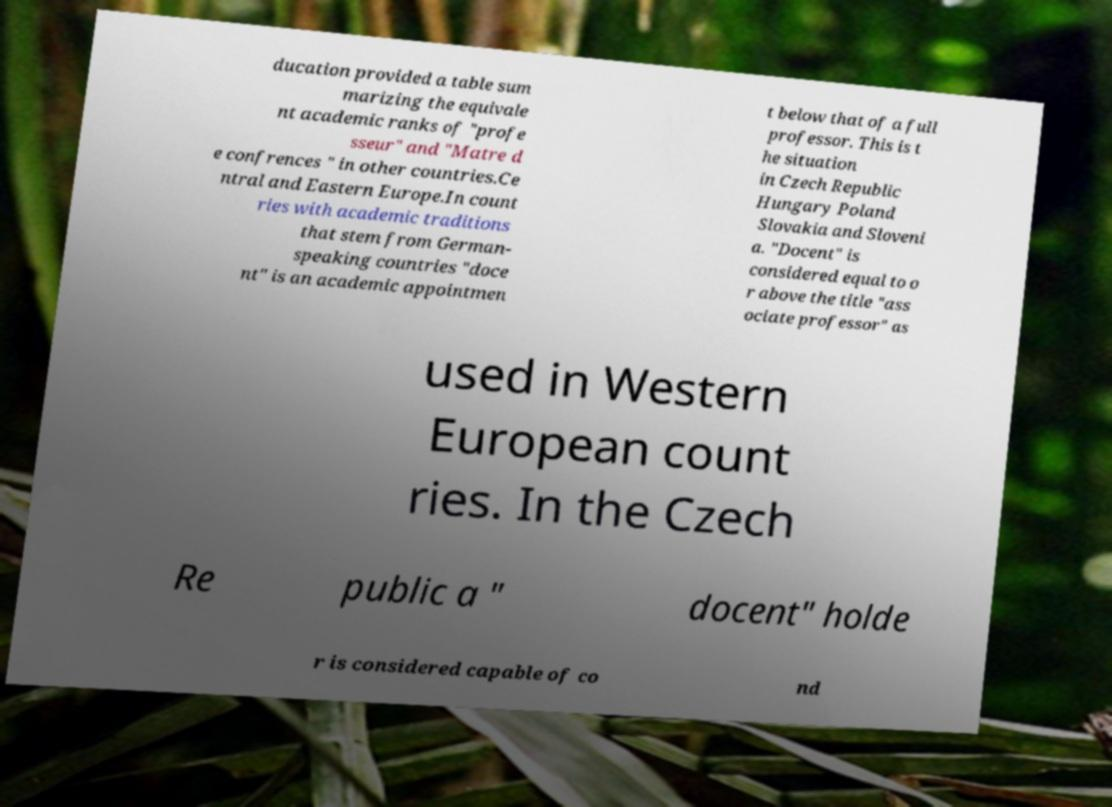For documentation purposes, I need the text within this image transcribed. Could you provide that? ducation provided a table sum marizing the equivale nt academic ranks of "profe sseur" and "Matre d e confrences " in other countries.Ce ntral and Eastern Europe.In count ries with academic traditions that stem from German- speaking countries "doce nt" is an academic appointmen t below that of a full professor. This is t he situation in Czech Republic Hungary Poland Slovakia and Sloveni a. "Docent" is considered equal to o r above the title "ass ociate professor" as used in Western European count ries. In the Czech Re public a " docent" holde r is considered capable of co nd 